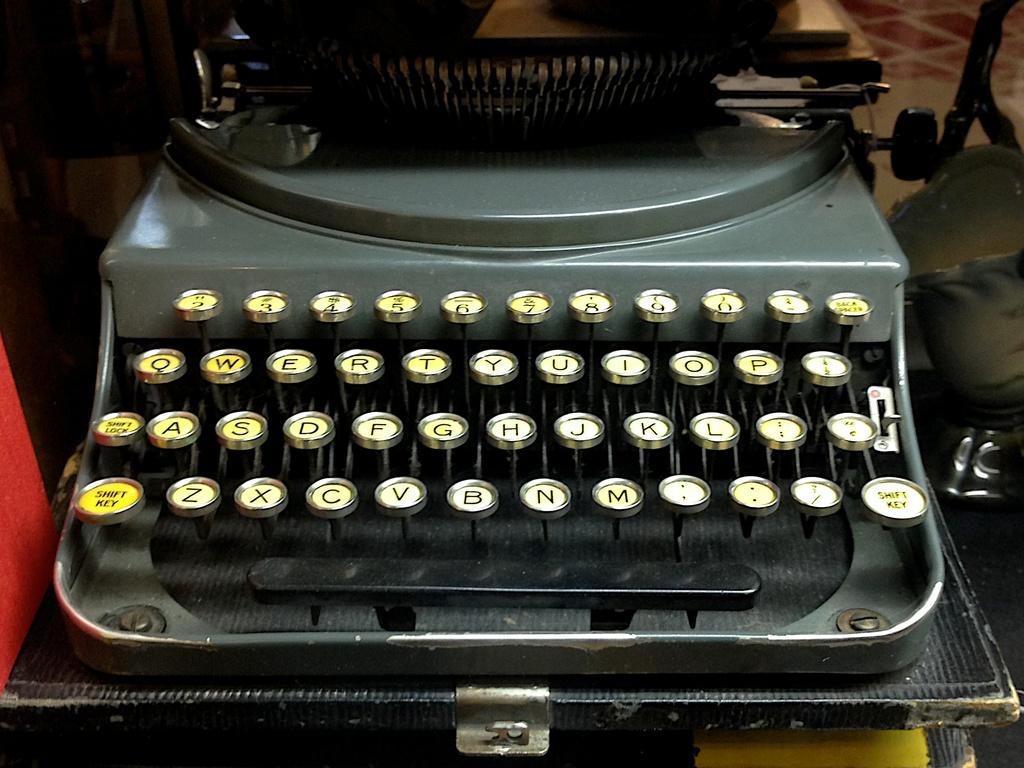Does the typewriter have lettering in the same way a computer keyboard does?
Make the answer very short. Yes. 